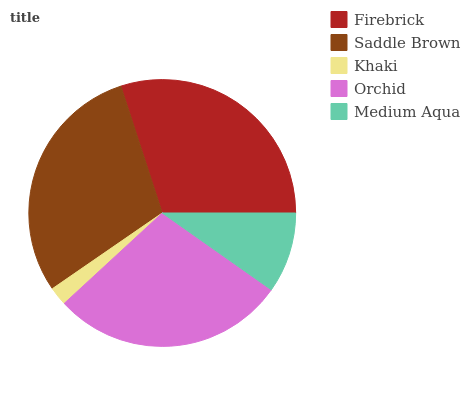Is Khaki the minimum?
Answer yes or no. Yes. Is Firebrick the maximum?
Answer yes or no. Yes. Is Saddle Brown the minimum?
Answer yes or no. No. Is Saddle Brown the maximum?
Answer yes or no. No. Is Firebrick greater than Saddle Brown?
Answer yes or no. Yes. Is Saddle Brown less than Firebrick?
Answer yes or no. Yes. Is Saddle Brown greater than Firebrick?
Answer yes or no. No. Is Firebrick less than Saddle Brown?
Answer yes or no. No. Is Orchid the high median?
Answer yes or no. Yes. Is Orchid the low median?
Answer yes or no. Yes. Is Firebrick the high median?
Answer yes or no. No. Is Saddle Brown the low median?
Answer yes or no. No. 